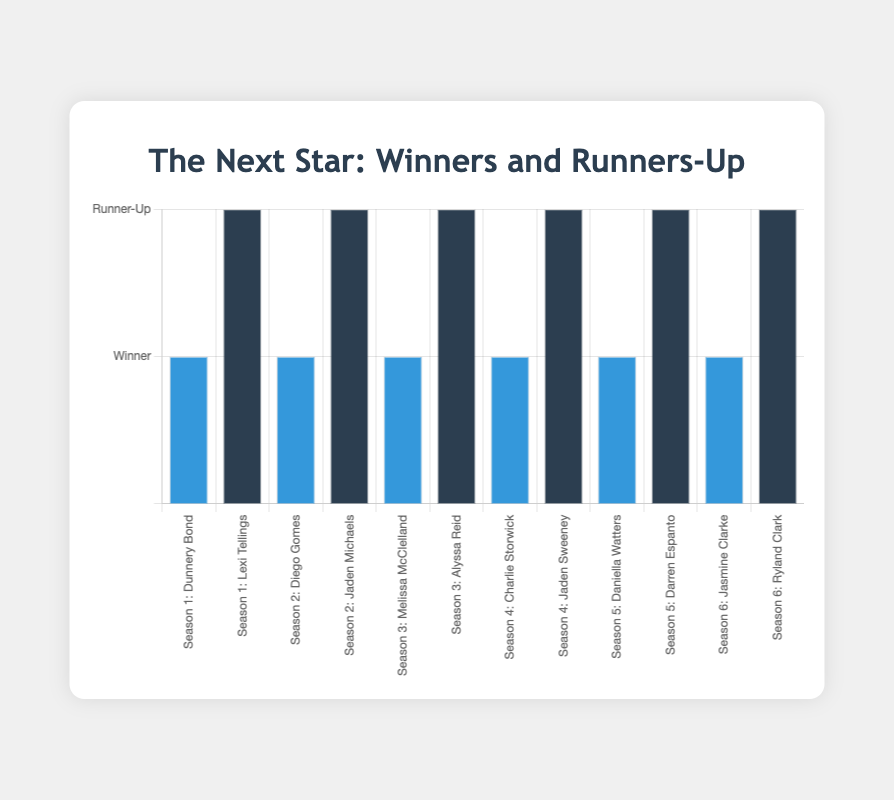What's the total number of seasons represented in the chart? Count the number of unique seasons on the x-axis. They range from 1 to 6.
Answer: 6 Which contestant is the winner of Season 4? Identify "Season 4" and look at the corresponding "Winner" bar in blue. The label shows "Charlie Storwick."
Answer: Charlie Storwick How many contestants were runners-up over all the seasons? Count the dark blue bars. There is one runner-up per season for a total of 6 seasons.
Answer: 6 Which season features Diego Gomes? Look for the label with "Diego Gomes" on the x-axis. The label shows "Season 2: Diego Gomes."
Answer: Season 2 Between which seasons are the runners-up Lexi Tellings and Jaden Michaels? Identify Lexi Tellings and Jaden Michaels in dark blue bars on the x-axis. Lexi Tellings is in Season 1, and Jaden Michaels is in Season 2.
Answer: Season 1 and Season 2 Which seasons have consecutive winners with names starting with "J"? Look for winners whose names start with "J." Jasmine Clarke (Season 6) and Jaden Sweeney (Season 4) are not consecutive. Other names in between do not start with "J."
Answer: None Which color represents the winners? Visually identify the color of the bars labeled as winners. They are all blue.
Answer: Blue Who is the runner-up in Season 5, and what color represents them? Identify the runner-up bar for Season 5 and note its label and color. It is "Darren Espanto" in dark blue.
Answer: Darren Espanto, Dark Blue Compare the number of winners and runners-up. Are they equal? Count the blue bars representing winners and the dark blue bars representing runners-up. Both are equal since there is one of each per season over six seasons.
Answer: Yes Who was the winner in Season 6? Identify the winner bar for Season 6, which is in blue. The label shows "Jasmine Clarke."
Answer: Jasmine Clarke 